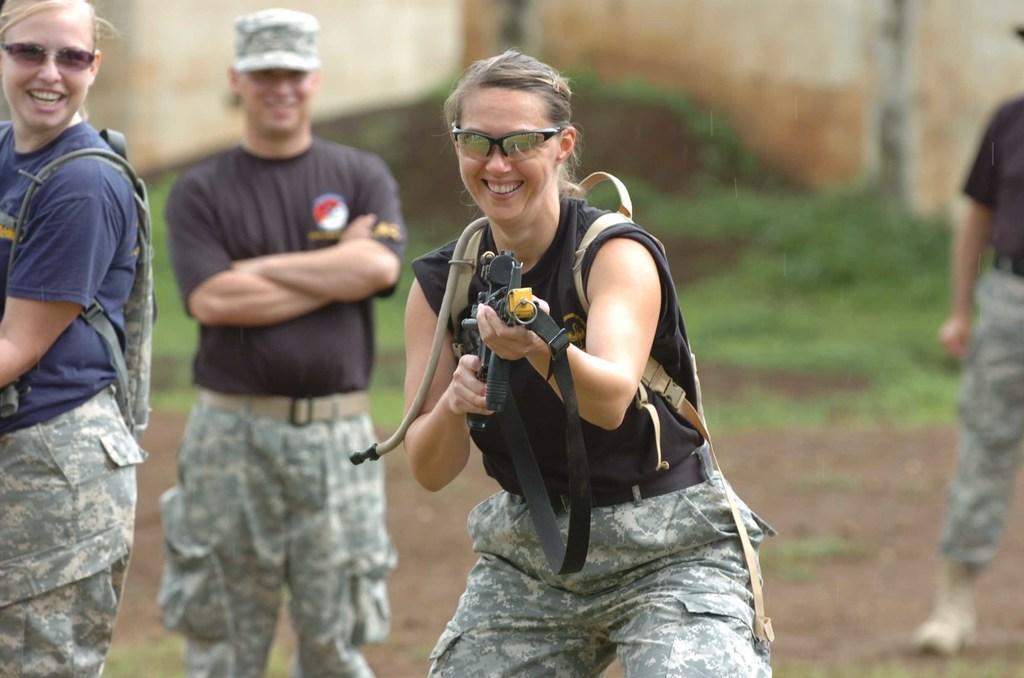Please provide a concise description of this image. In this image I can see a woman wearing black and green colored dress is standing and holding a weapon in her hand. In the background I can see few other persons standing, the ground, some grass and the wall. 